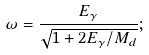Convert formula to latex. <formula><loc_0><loc_0><loc_500><loc_500>\omega = \frac { E _ { \gamma } } { \sqrt { 1 + 2 E _ { \gamma } / M _ { d } } } ;</formula> 